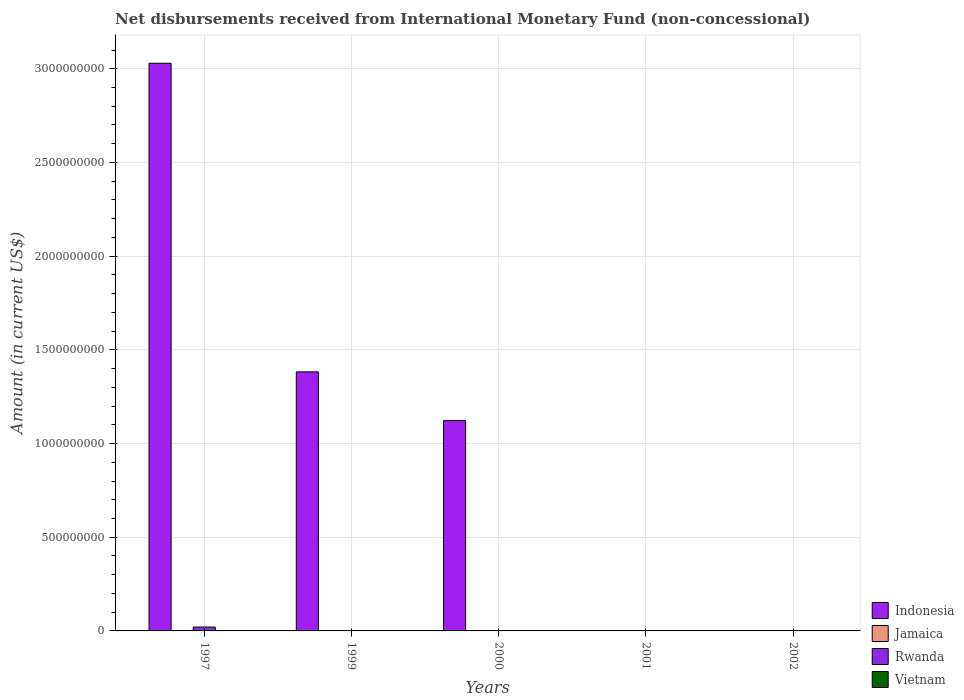How many different coloured bars are there?
Your answer should be compact. 2. Are the number of bars on each tick of the X-axis equal?
Your answer should be compact. No. How many bars are there on the 2nd tick from the right?
Your answer should be compact. 0. What is the label of the 1st group of bars from the left?
Your answer should be compact. 1997. What is the amount of disbursements received from International Monetary Fund in Indonesia in 1997?
Make the answer very short. 3.03e+09. Across all years, what is the maximum amount of disbursements received from International Monetary Fund in Indonesia?
Provide a short and direct response. 3.03e+09. Across all years, what is the minimum amount of disbursements received from International Monetary Fund in Jamaica?
Your response must be concise. 0. What is the total amount of disbursements received from International Monetary Fund in Vietnam in the graph?
Provide a succinct answer. 0. What is the average amount of disbursements received from International Monetary Fund in Rwanda per year?
Your answer should be compact. 4.09e+06. In how many years, is the amount of disbursements received from International Monetary Fund in Vietnam greater than 600000000 US$?
Your answer should be compact. 0. Is the amount of disbursements received from International Monetary Fund in Indonesia in 1997 less than that in 2000?
Ensure brevity in your answer.  No. What is the difference between the highest and the lowest amount of disbursements received from International Monetary Fund in Rwanda?
Provide a short and direct response. 2.05e+07. In how many years, is the amount of disbursements received from International Monetary Fund in Indonesia greater than the average amount of disbursements received from International Monetary Fund in Indonesia taken over all years?
Offer a terse response. 3. How many bars are there?
Give a very brief answer. 4. Does the graph contain any zero values?
Give a very brief answer. Yes. How many legend labels are there?
Give a very brief answer. 4. How are the legend labels stacked?
Your answer should be compact. Vertical. What is the title of the graph?
Offer a terse response. Net disbursements received from International Monetary Fund (non-concessional). What is the label or title of the X-axis?
Your answer should be compact. Years. What is the label or title of the Y-axis?
Your response must be concise. Amount (in current US$). What is the Amount (in current US$) in Indonesia in 1997?
Ensure brevity in your answer.  3.03e+09. What is the Amount (in current US$) in Jamaica in 1997?
Give a very brief answer. 0. What is the Amount (in current US$) in Rwanda in 1997?
Your response must be concise. 2.05e+07. What is the Amount (in current US$) of Vietnam in 1997?
Ensure brevity in your answer.  0. What is the Amount (in current US$) of Indonesia in 1999?
Provide a succinct answer. 1.38e+09. What is the Amount (in current US$) of Rwanda in 1999?
Ensure brevity in your answer.  0. What is the Amount (in current US$) in Indonesia in 2000?
Give a very brief answer. 1.12e+09. What is the Amount (in current US$) of Rwanda in 2000?
Offer a very short reply. 0. What is the Amount (in current US$) in Rwanda in 2001?
Ensure brevity in your answer.  0. What is the Amount (in current US$) of Vietnam in 2001?
Your answer should be compact. 0. What is the Amount (in current US$) of Jamaica in 2002?
Your answer should be very brief. 0. What is the Amount (in current US$) in Rwanda in 2002?
Ensure brevity in your answer.  0. What is the Amount (in current US$) of Vietnam in 2002?
Your answer should be very brief. 0. Across all years, what is the maximum Amount (in current US$) in Indonesia?
Provide a succinct answer. 3.03e+09. Across all years, what is the maximum Amount (in current US$) of Rwanda?
Offer a terse response. 2.05e+07. Across all years, what is the minimum Amount (in current US$) of Indonesia?
Your response must be concise. 0. Across all years, what is the minimum Amount (in current US$) in Rwanda?
Keep it short and to the point. 0. What is the total Amount (in current US$) of Indonesia in the graph?
Offer a very short reply. 5.53e+09. What is the total Amount (in current US$) in Rwanda in the graph?
Provide a succinct answer. 2.05e+07. What is the total Amount (in current US$) in Vietnam in the graph?
Your answer should be compact. 0. What is the difference between the Amount (in current US$) of Indonesia in 1997 and that in 1999?
Your response must be concise. 1.65e+09. What is the difference between the Amount (in current US$) of Indonesia in 1997 and that in 2000?
Provide a short and direct response. 1.91e+09. What is the difference between the Amount (in current US$) in Indonesia in 1999 and that in 2000?
Keep it short and to the point. 2.60e+08. What is the average Amount (in current US$) in Indonesia per year?
Make the answer very short. 1.11e+09. What is the average Amount (in current US$) of Jamaica per year?
Your response must be concise. 0. What is the average Amount (in current US$) in Rwanda per year?
Your response must be concise. 4.09e+06. What is the average Amount (in current US$) in Vietnam per year?
Your answer should be compact. 0. In the year 1997, what is the difference between the Amount (in current US$) of Indonesia and Amount (in current US$) of Rwanda?
Your answer should be compact. 3.01e+09. What is the ratio of the Amount (in current US$) of Indonesia in 1997 to that in 1999?
Offer a very short reply. 2.19. What is the ratio of the Amount (in current US$) of Indonesia in 1997 to that in 2000?
Your answer should be very brief. 2.7. What is the ratio of the Amount (in current US$) of Indonesia in 1999 to that in 2000?
Ensure brevity in your answer.  1.23. What is the difference between the highest and the second highest Amount (in current US$) of Indonesia?
Make the answer very short. 1.65e+09. What is the difference between the highest and the lowest Amount (in current US$) of Indonesia?
Provide a succinct answer. 3.03e+09. What is the difference between the highest and the lowest Amount (in current US$) in Rwanda?
Your answer should be very brief. 2.05e+07. 